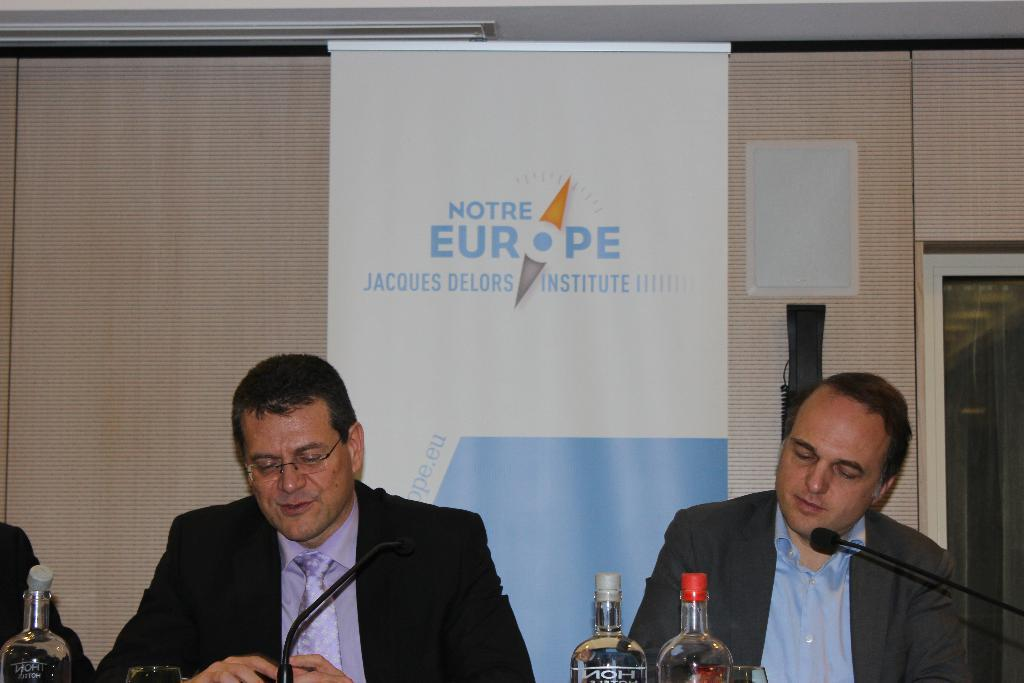<image>
Describe the image concisely. Two men sit at a desk behind microphones and in front of a sign that says Notre Europe 